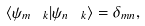<formula> <loc_0><loc_0><loc_500><loc_500>\langle \psi _ { m \ k } | \psi _ { n \ k } \rangle = \delta _ { m n } ,</formula> 